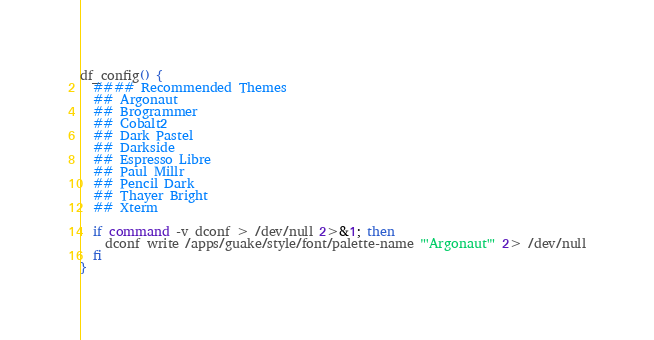<code> <loc_0><loc_0><loc_500><loc_500><_Bash_>df_config() {
  #### Recommended Themes
  ## Argonaut
  ## Brogrammer
  ## Cobalt2
  ## Dark Pastel
  ## Darkside
  ## Espresso Libre
  ## Paul Millr
  ## Pencil Dark
  ## Thayer Bright
  ## Xterm

  if command -v dconf > /dev/null 2>&1; then
    dconf write /apps/guake/style/font/palette-name "'Argonaut'" 2> /dev/null
  fi
}
</code> 